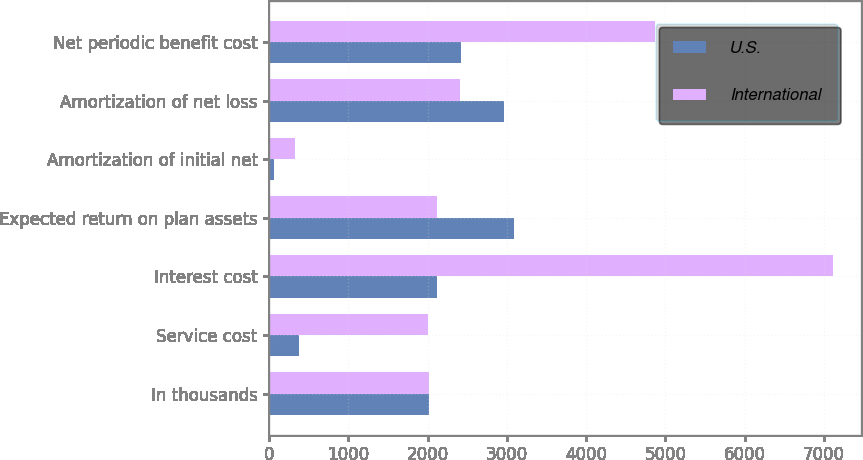Convert chart to OTSL. <chart><loc_0><loc_0><loc_500><loc_500><stacked_bar_chart><ecel><fcel>In thousands<fcel>Service cost<fcel>Interest cost<fcel>Expected return on plan assets<fcel>Amortization of initial net<fcel>Amortization of net loss<fcel>Net periodic benefit cost<nl><fcel>U.S.<fcel>2012<fcel>379<fcel>2113<fcel>3095<fcel>62<fcel>2968<fcel>2427<nl><fcel>International<fcel>2012<fcel>2006<fcel>7114<fcel>2113<fcel>322<fcel>2412<fcel>4871<nl></chart> 